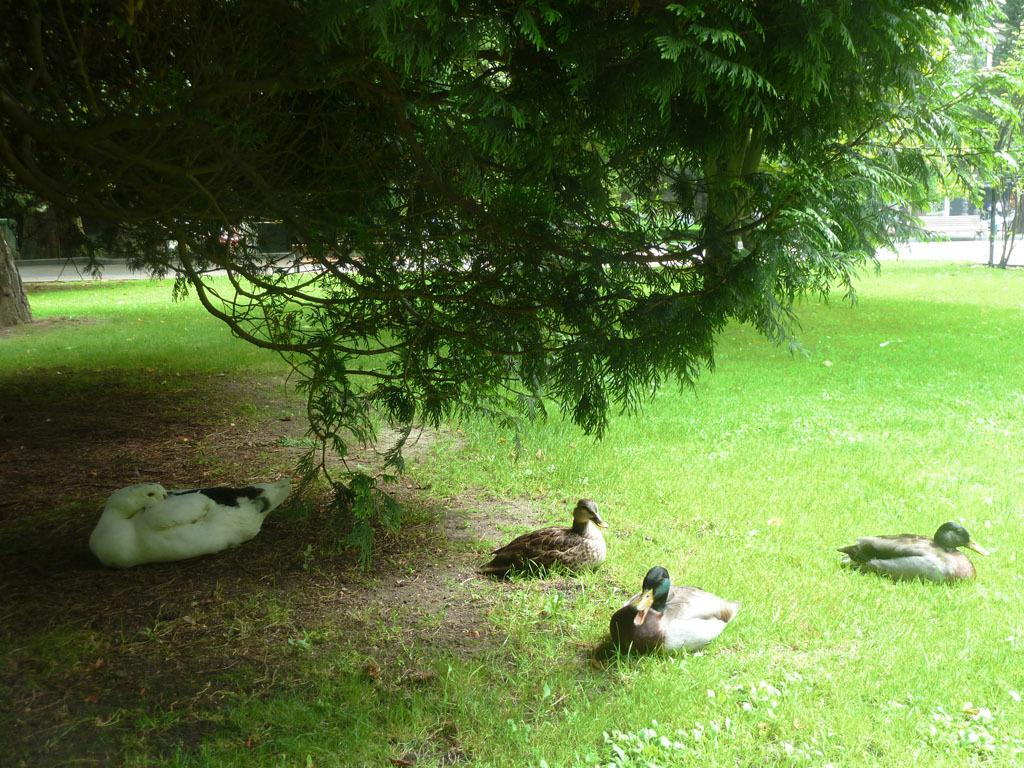What animals can be seen at the bottom of the picture? There are ducks at the bottom of the picture. What type of vegetation is present at the bottom of the picture? There is grass at the bottom of the picture. What can be seen at the top of the picture? There are trees at the top of the picture. What is visible in the background of the picture? There are trees and a building in the background of the picture. What type of zephyr can be seen flying over the trees in the image? There is no zephyr present in the image; it is a term used to describe a gentle breeze, and there is no indication of wind or any flying objects in the image. Is there a plane visible in the image? No, there is no plane present in the image. 